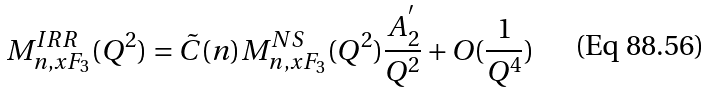<formula> <loc_0><loc_0><loc_500><loc_500>M _ { n , x F _ { 3 } } ^ { I R R } ( Q ^ { 2 } ) = \tilde { C } ( n ) M _ { n , x F _ { 3 } } ^ { N S } ( Q ^ { 2 } ) \frac { A _ { 2 } ^ { ^ { \prime } } } { Q ^ { 2 } } + O ( \frac { 1 } { Q ^ { 4 } } )</formula> 